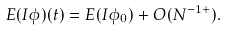Convert formula to latex. <formula><loc_0><loc_0><loc_500><loc_500>E ( I \phi ) ( t ) & = E ( I \phi _ { 0 } ) + O ( N ^ { - 1 + } ) .</formula> 